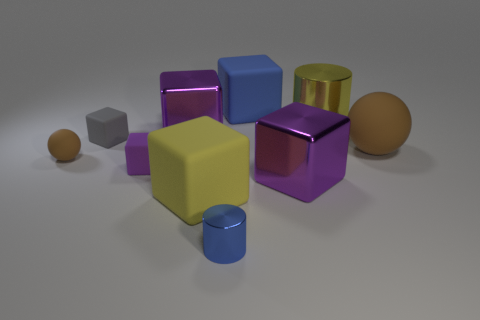Are there any other things of the same color as the big rubber sphere?
Give a very brief answer. Yes. Are there any purple rubber blocks in front of the big purple cube that is in front of the large matte thing on the right side of the large blue cube?
Make the answer very short. No. Is the shape of the metal object in front of the yellow cube the same as  the large yellow metallic object?
Your answer should be compact. Yes. Is the number of large purple cubes to the right of the big rubber ball less than the number of rubber cubes that are left of the small ball?
Make the answer very short. No. What material is the tiny purple cube?
Give a very brief answer. Rubber. There is a small cylinder; does it have the same color as the big matte thing to the left of the large blue rubber block?
Provide a short and direct response. No. What number of big yellow shiny things are to the left of the big blue matte object?
Your answer should be very brief. 0. Are there fewer big matte objects that are behind the tiny purple block than yellow cylinders?
Ensure brevity in your answer.  No. The big ball has what color?
Offer a very short reply. Brown. There is a small matte cube that is behind the purple rubber thing; is it the same color as the large metallic cylinder?
Keep it short and to the point. No. 